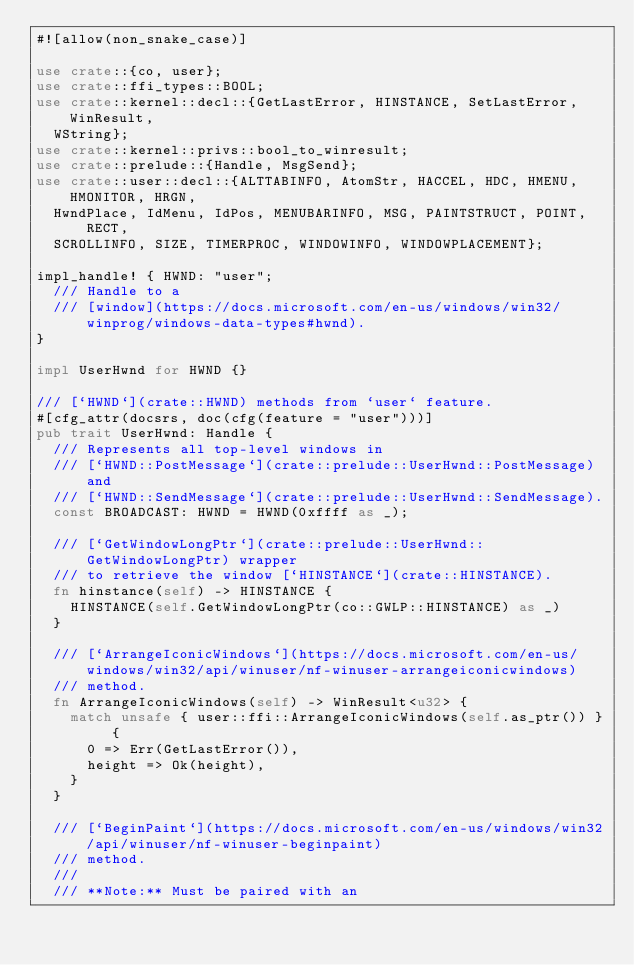<code> <loc_0><loc_0><loc_500><loc_500><_Rust_>#![allow(non_snake_case)]

use crate::{co, user};
use crate::ffi_types::BOOL;
use crate::kernel::decl::{GetLastError, HINSTANCE, SetLastError, WinResult,
	WString};
use crate::kernel::privs::bool_to_winresult;
use crate::prelude::{Handle, MsgSend};
use crate::user::decl::{ALTTABINFO, AtomStr, HACCEL, HDC, HMENU, HMONITOR, HRGN,
	HwndPlace, IdMenu, IdPos, MENUBARINFO, MSG, PAINTSTRUCT, POINT, RECT,
	SCROLLINFO, SIZE, TIMERPROC, WINDOWINFO, WINDOWPLACEMENT};

impl_handle! { HWND: "user";
	/// Handle to a
	/// [window](https://docs.microsoft.com/en-us/windows/win32/winprog/windows-data-types#hwnd).
}

impl UserHwnd for HWND {}

/// [`HWND`](crate::HWND) methods from `user` feature.
#[cfg_attr(docsrs, doc(cfg(feature = "user")))]
pub trait UserHwnd: Handle {
	/// Represents all top-level windows in
	/// [`HWND::PostMessage`](crate::prelude::UserHwnd::PostMessage) and
	/// [`HWND::SendMessage`](crate::prelude::UserHwnd::SendMessage).
	const BROADCAST: HWND = HWND(0xffff as _);

	/// [`GetWindowLongPtr`](crate::prelude::UserHwnd::GetWindowLongPtr) wrapper
	/// to retrieve the window [`HINSTANCE`](crate::HINSTANCE).
	fn hinstance(self) -> HINSTANCE {
		HINSTANCE(self.GetWindowLongPtr(co::GWLP::HINSTANCE) as _)
	}

	/// [`ArrangeIconicWindows`](https://docs.microsoft.com/en-us/windows/win32/api/winuser/nf-winuser-arrangeiconicwindows)
	/// method.
	fn ArrangeIconicWindows(self) -> WinResult<u32> {
		match unsafe { user::ffi::ArrangeIconicWindows(self.as_ptr()) } {
			0 => Err(GetLastError()),
			height => Ok(height),
		}
	}

	/// [`BeginPaint`](https://docs.microsoft.com/en-us/windows/win32/api/winuser/nf-winuser-beginpaint)
	/// method.
	///
	/// **Note:** Must be paired with an</code> 